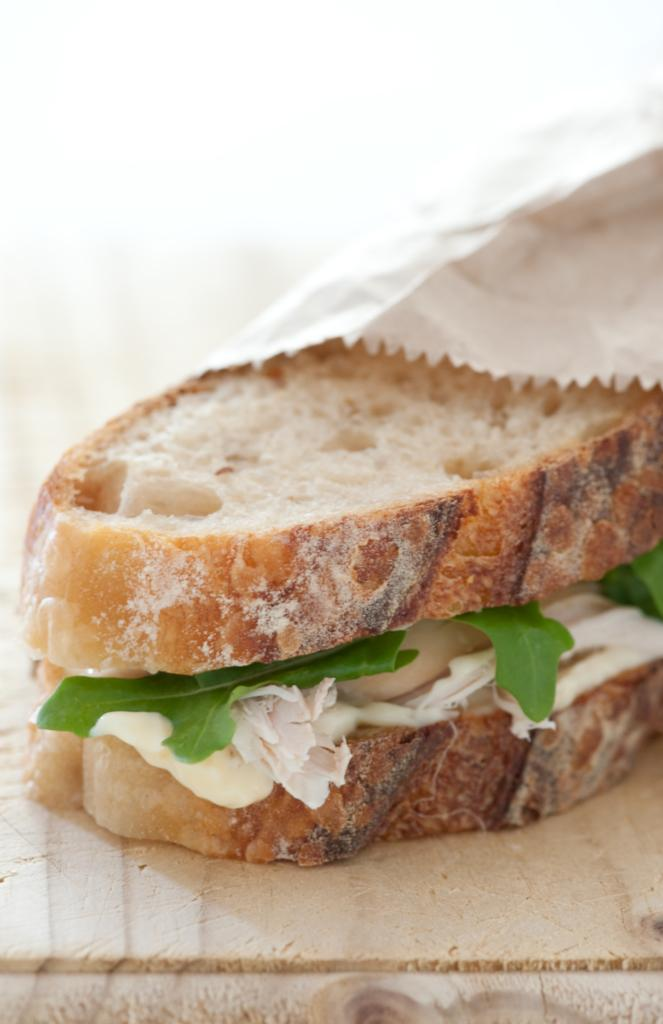What is the main object made of in the image? There is a wooden plank in the image. What type of food can be seen in the image? There is a bread slice and cheese in the image. What type of vegetation is present in the image? There are leaves in the image. What is covering some parts of the image? Some parts of the image are covered with a paper cover. Can you see a boat in the image? There is no boat present in the image. Is there a bat flying in the image? There is no bat present in the image. 